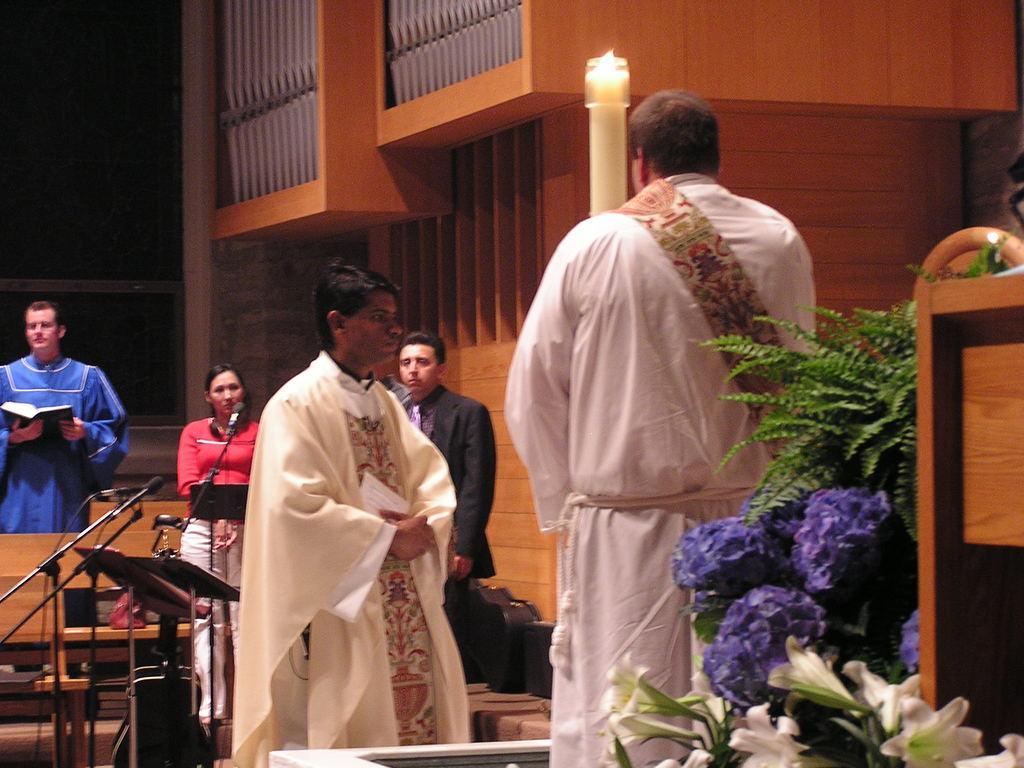Please provide a concise description of this image. In this picture I can see some people are standing and holding books, side there is a wall and some flower. 